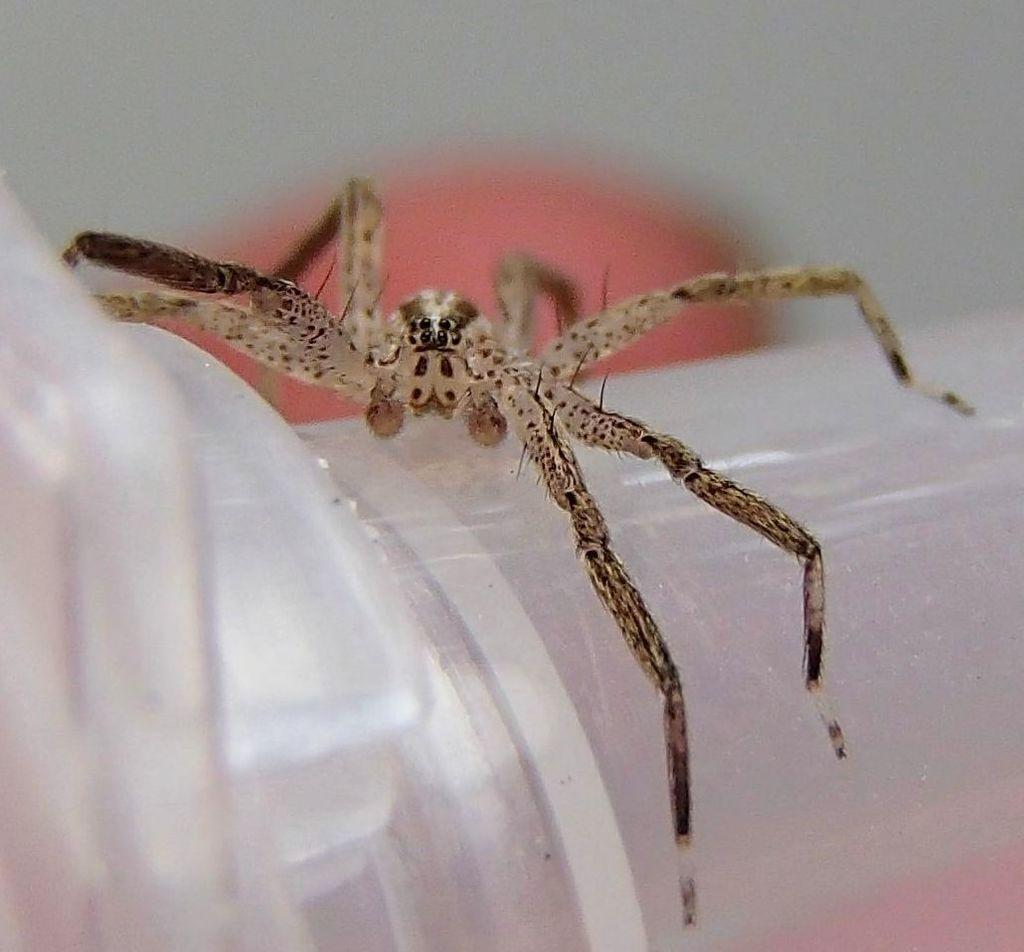What type of creature can be seen in the image? There is an insect in the image. What is the insect located on in the image? The insect is on an object. Can you describe the background of the image? The background of the image is blurred. What type of cakes can be seen being prepared in the image? There is no reference to cakes or any food preparation in the image, as it features an insect on an object with a blurred background. What type of music can be heard playing in the background of the image? There is no music or any sound present in the image, as it only shows an insect on an object with a blurred background. 